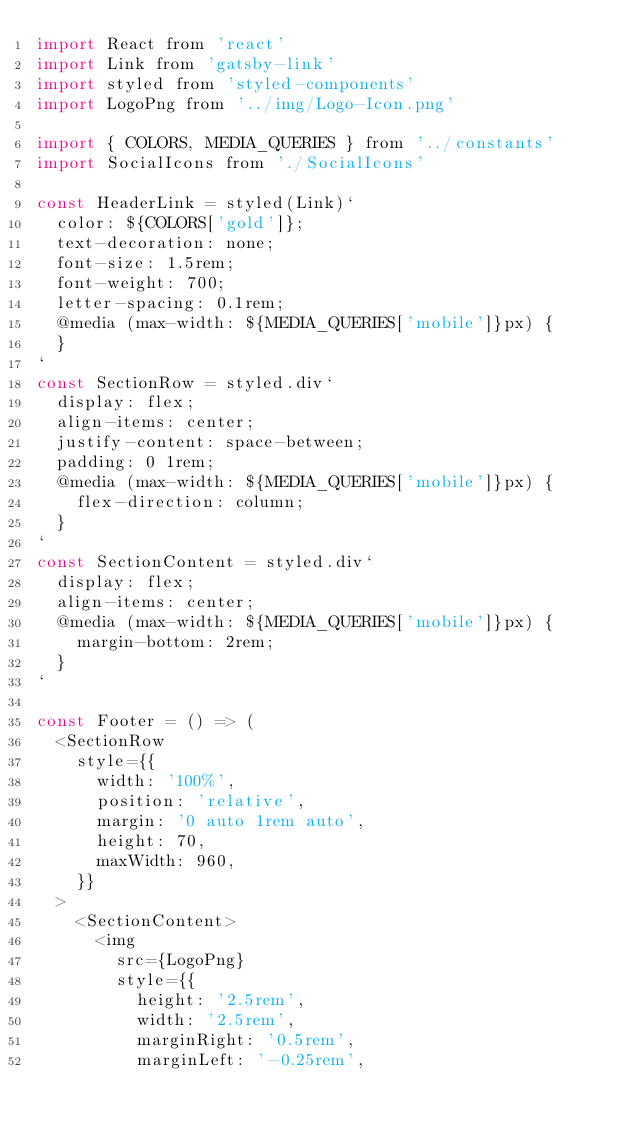Convert code to text. <code><loc_0><loc_0><loc_500><loc_500><_JavaScript_>import React from 'react'
import Link from 'gatsby-link'
import styled from 'styled-components'
import LogoPng from '../img/Logo-Icon.png'

import { COLORS, MEDIA_QUERIES } from '../constants'
import SocialIcons from './SocialIcons'

const HeaderLink = styled(Link)`
  color: ${COLORS['gold']};
  text-decoration: none;
  font-size: 1.5rem;
  font-weight: 700;
  letter-spacing: 0.1rem;
  @media (max-width: ${MEDIA_QUERIES['mobile']}px) {
  }
`
const SectionRow = styled.div`
  display: flex;
  align-items: center;
  justify-content: space-between;
  padding: 0 1rem;
  @media (max-width: ${MEDIA_QUERIES['mobile']}px) {
    flex-direction: column;
  }
`
const SectionContent = styled.div`
  display: flex;
  align-items: center;
  @media (max-width: ${MEDIA_QUERIES['mobile']}px) {
    margin-bottom: 2rem;
  }
`

const Footer = () => (
  <SectionRow
    style={{
      width: '100%',
      position: 'relative',
      margin: '0 auto 1rem auto',
      height: 70,
      maxWidth: 960,
    }}
  >
    <SectionContent>
      <img
        src={LogoPng}
        style={{
          height: '2.5rem',
          width: '2.5rem',
          marginRight: '0.5rem',
          marginLeft: '-0.25rem',</code> 